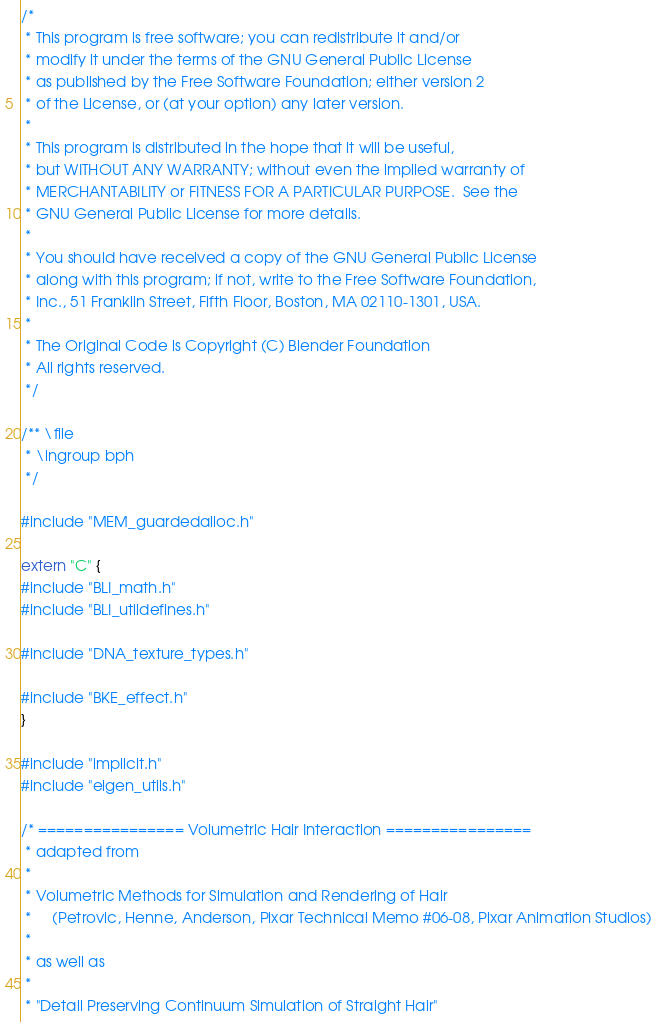Convert code to text. <code><loc_0><loc_0><loc_500><loc_500><_C++_>/*
 * This program is free software; you can redistribute it and/or
 * modify it under the terms of the GNU General Public License
 * as published by the Free Software Foundation; either version 2
 * of the License, or (at your option) any later version.
 *
 * This program is distributed in the hope that it will be useful,
 * but WITHOUT ANY WARRANTY; without even the implied warranty of
 * MERCHANTABILITY or FITNESS FOR A PARTICULAR PURPOSE.  See the
 * GNU General Public License for more details.
 *
 * You should have received a copy of the GNU General Public License
 * along with this program; if not, write to the Free Software Foundation,
 * Inc., 51 Franklin Street, Fifth Floor, Boston, MA 02110-1301, USA.
 *
 * The Original Code is Copyright (C) Blender Foundation
 * All rights reserved.
 */

/** \file
 * \ingroup bph
 */

#include "MEM_guardedalloc.h"

extern "C" {
#include "BLI_math.h"
#include "BLI_utildefines.h"

#include "DNA_texture_types.h"

#include "BKE_effect.h"
}

#include "implicit.h"
#include "eigen_utils.h"

/* ================ Volumetric Hair Interaction ================
 * adapted from
 *
 * Volumetric Methods for Simulation and Rendering of Hair
 *     (Petrovic, Henne, Anderson, Pixar Technical Memo #06-08, Pixar Animation Studios)
 *
 * as well as
 *
 * "Detail Preserving Continuum Simulation of Straight Hair"</code> 